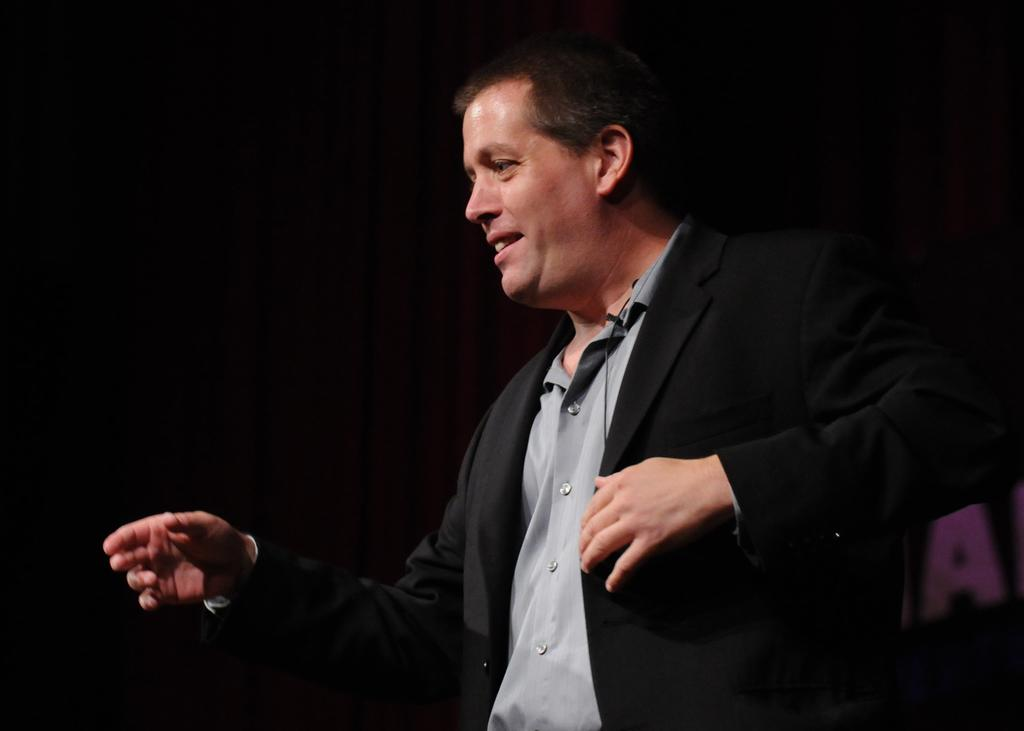What is the main subject of the image? There is a man in the image. What is the man wearing? The man is wearing a black suit and a grey shirt. What is the man doing in the image? The man is standing. What can be observed about the background of the image? The background of the image is dark. Can you hear the man laughing in the image? There is no sound in the image, so it is not possible to hear the man laughing. What type of paint is being used by the man in the image? There is no paint or painting activity depicted in the image. 